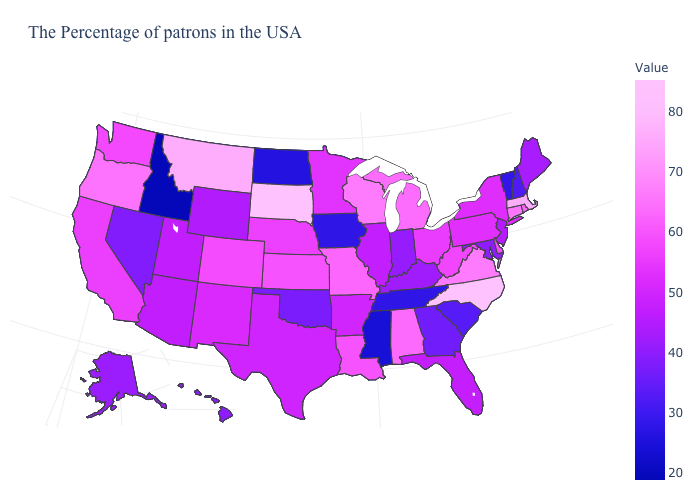Which states hav the highest value in the MidWest?
Be succinct. South Dakota. Does Mississippi have the lowest value in the USA?
Be succinct. No. Among the states that border Arizona , which have the lowest value?
Short answer required. Nevada. 